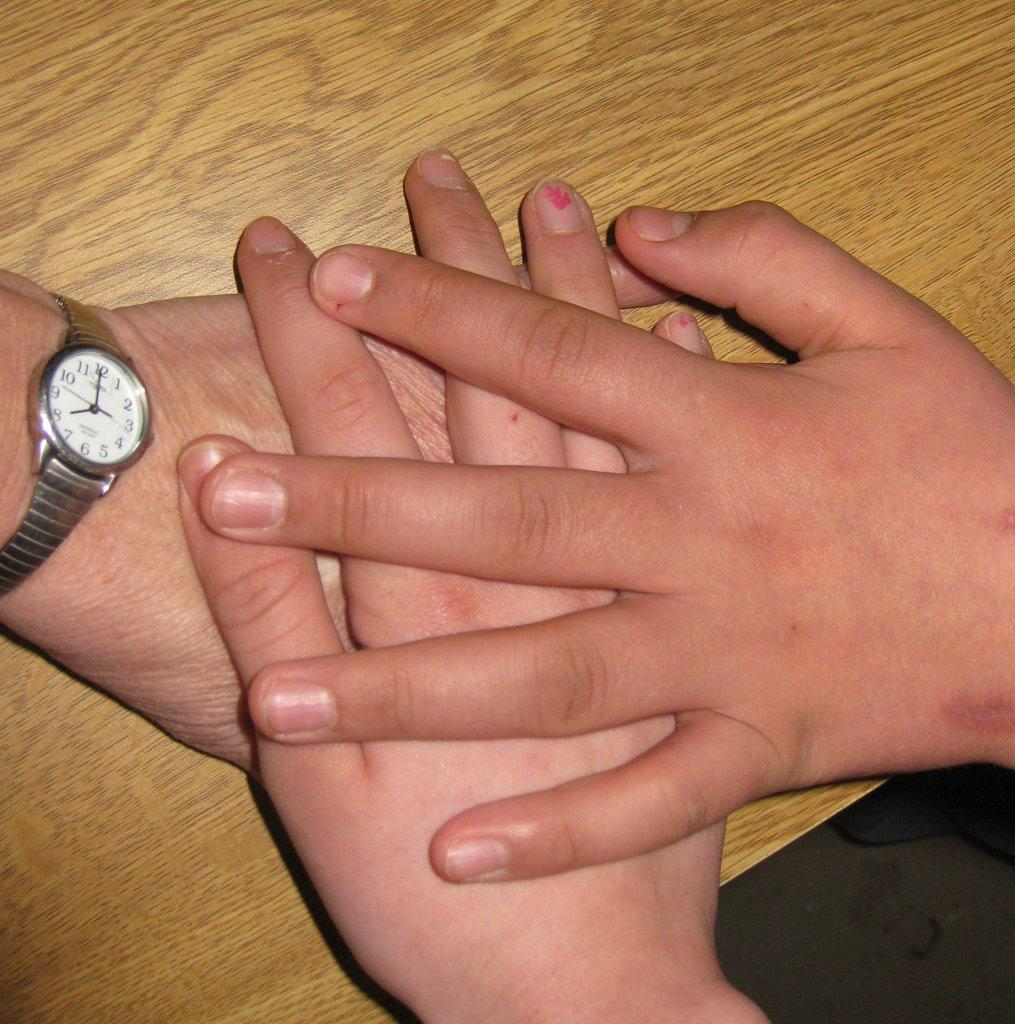Provide a one-sentence caption for the provided image. Several different hands laying on a table stacked on top of each other with a Timex watch reading 8:00 on one wrist. 